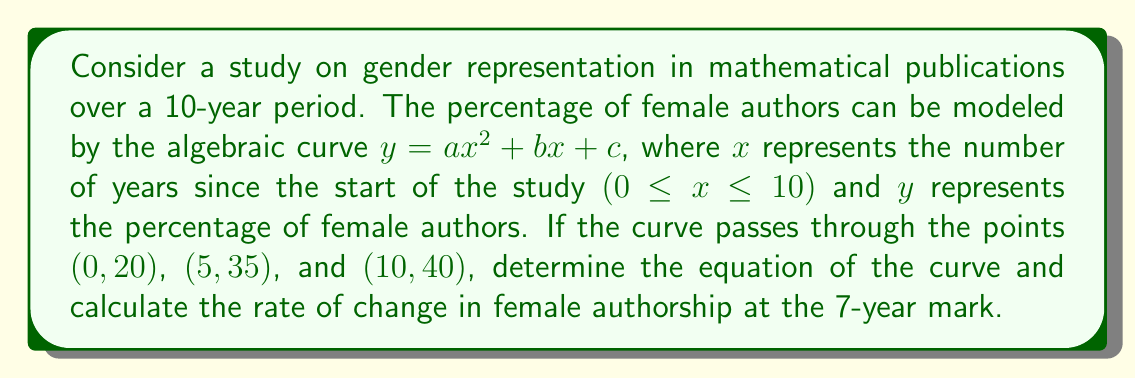Could you help me with this problem? 1) We need to find the values of $a$, $b$, and $c$ in the equation $y = ax^2 + bx + c$. We can use the given points to create a system of equations:

   20 = a(0)^2 + b(0) + c
   35 = a(5)^2 + b(5) + c
   40 = a(10)^2 + b(10) + c

2) Simplify:
   20 = c
   35 = 25a + 5b + 20
   40 = 100a + 10b + 20

3) Substitute c = 20 into the other equations:
   15 = 25a + 5b
   20 = 100a + 10b

4) Multiply the first equation by 2 and subtract from the second:
   30 = 50a + 10b
   20 = 100a + 10b
   10 = -50a

5) Solve for a:
   a = -1/5 = -0.2

6) Substitute this back into 15 = 25a + 5b:
   15 = 25(-0.2) + 5b
   15 = -5 + 5b
   20 = 5b
   b = 4

7) The equation of the curve is:
   $y = -0.2x^2 + 4x + 20$

8) To find the rate of change at x = 7, we need to find the derivative of the curve and evaluate it at x = 7:
   $\frac{dy}{dx} = -0.4x + 4$
   At x = 7: $\frac{dy}{dx} = -0.4(7) + 4 = 1.2$
Answer: $y = -0.2x^2 + 4x + 20$; Rate of change at 7 years: 1.2% per year 